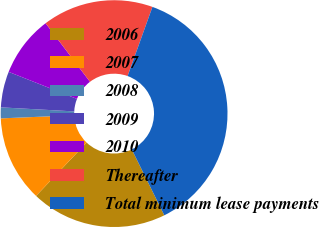<chart> <loc_0><loc_0><loc_500><loc_500><pie_chart><fcel>2006<fcel>2007<fcel>2008<fcel>2009<fcel>2010<fcel>Thereafter<fcel>Total minimum lease payments<nl><fcel>19.38%<fcel>12.25%<fcel>1.55%<fcel>5.12%<fcel>8.68%<fcel>15.81%<fcel>37.21%<nl></chart> 